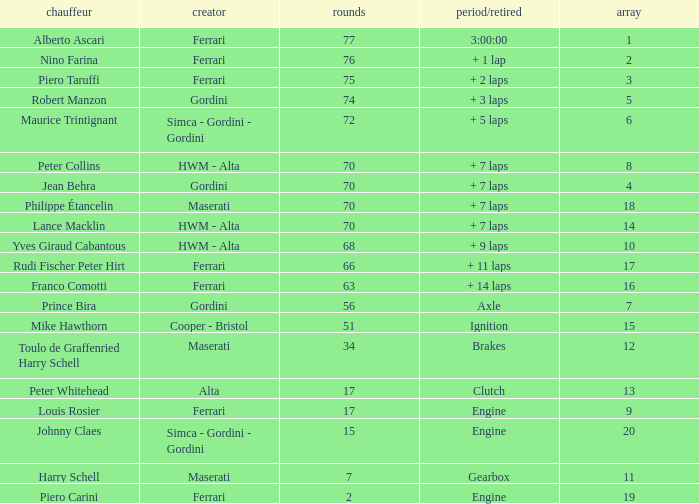How many grids for peter collins? 1.0. 